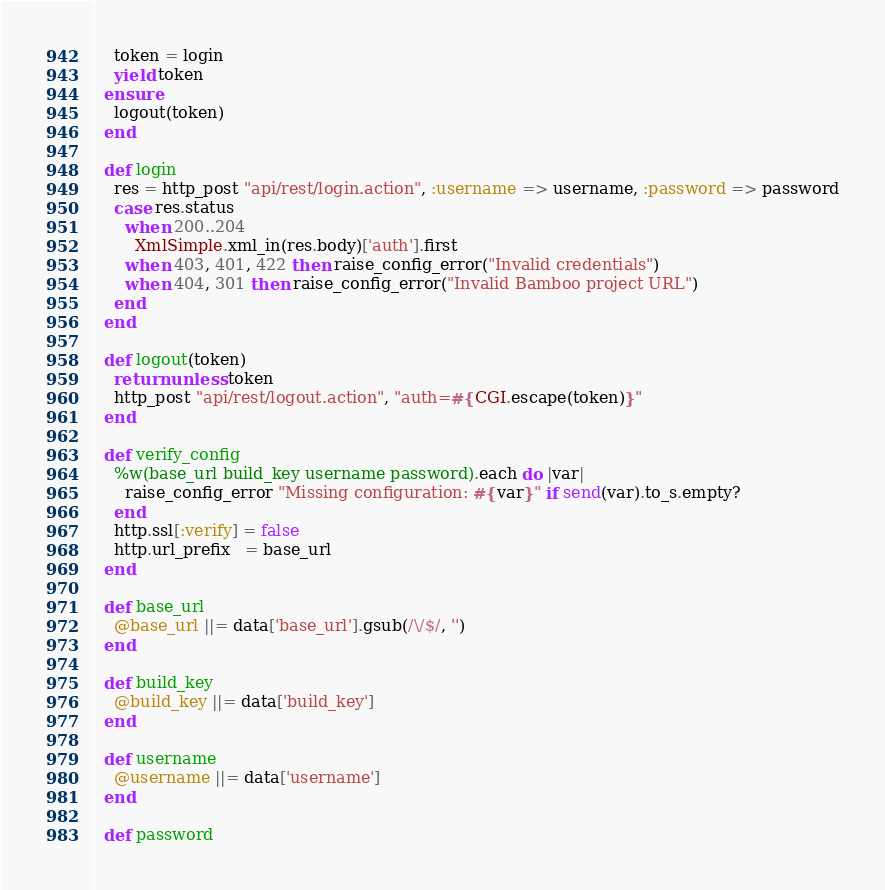Convert code to text. <code><loc_0><loc_0><loc_500><loc_500><_Ruby_>    token = login
    yield token
  ensure
    logout(token)
  end

  def login
    res = http_post "api/rest/login.action", :username => username, :password => password
    case res.status
      when 200..204
        XmlSimple.xml_in(res.body)['auth'].first
      when 403, 401, 422 then raise_config_error("Invalid credentials")
      when 404, 301 then raise_config_error("Invalid Bamboo project URL")
    end
  end

  def logout(token)
    return unless token
    http_post "api/rest/logout.action", "auth=#{CGI.escape(token)}"
  end

  def verify_config
    %w(base_url build_key username password).each do |var|
      raise_config_error "Missing configuration: #{var}" if send(var).to_s.empty?
    end
    http.ssl[:verify] = false
    http.url_prefix   = base_url
  end

  def base_url
    @base_url ||= data['base_url'].gsub(/\/$/, '')
  end

  def build_key
    @build_key ||= data['build_key']
  end

  def username
    @username ||= data['username']
  end

  def password</code> 